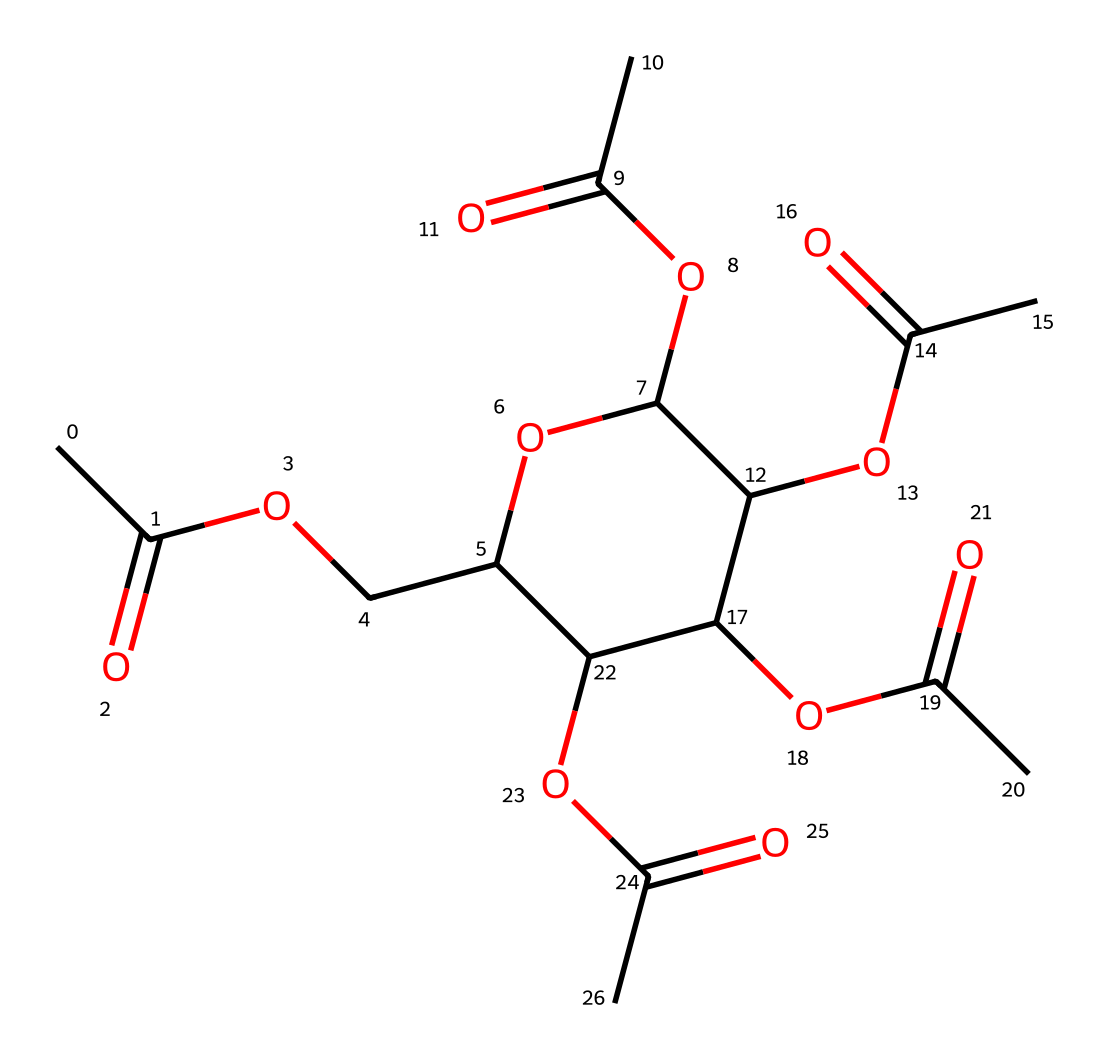What is the primary functional group in cellulose acetate? The chemical structure contains multiple ester groups, which are characterized by the presence of the -O-C(=O)- fragment. This indicates that cellulose acetate primarily features ester functional groups.
Answer: ester How many carbon atoms are in this molecule? By examining the SMILES representation, I can count 12 carbon atoms in the structure, which includes all the carbon atoms that are part of the chains and functional groups.
Answer: 12 What type of polymer is cellulose acetate classified as? Cellulose acetate is classified as a cellulose derivative, which identifies it as a type of polymer formed from the modification of cellulose.
Answer: cellulose derivative How many ester linkages are present in this molecule? The structure shows that there are 5 ester linkages present, as indicated by the count of the -O-C(=O)- patterns in the polymer chain.
Answer: 5 What is the degree of polymerization suggested by the structure? The structure highlights multiple repeating units, implying a moderate degree of polymerization around 5-10 based on the arrangement of functional groups and chain length.
Answer: approximately 5-10 What general property does cellulose acetate exhibit due to its structure? The presence of multiple ester groups within the polymer backbone contributes to its biodegradability, which is a significant property of cellulose acetate.
Answer: biodegradability 